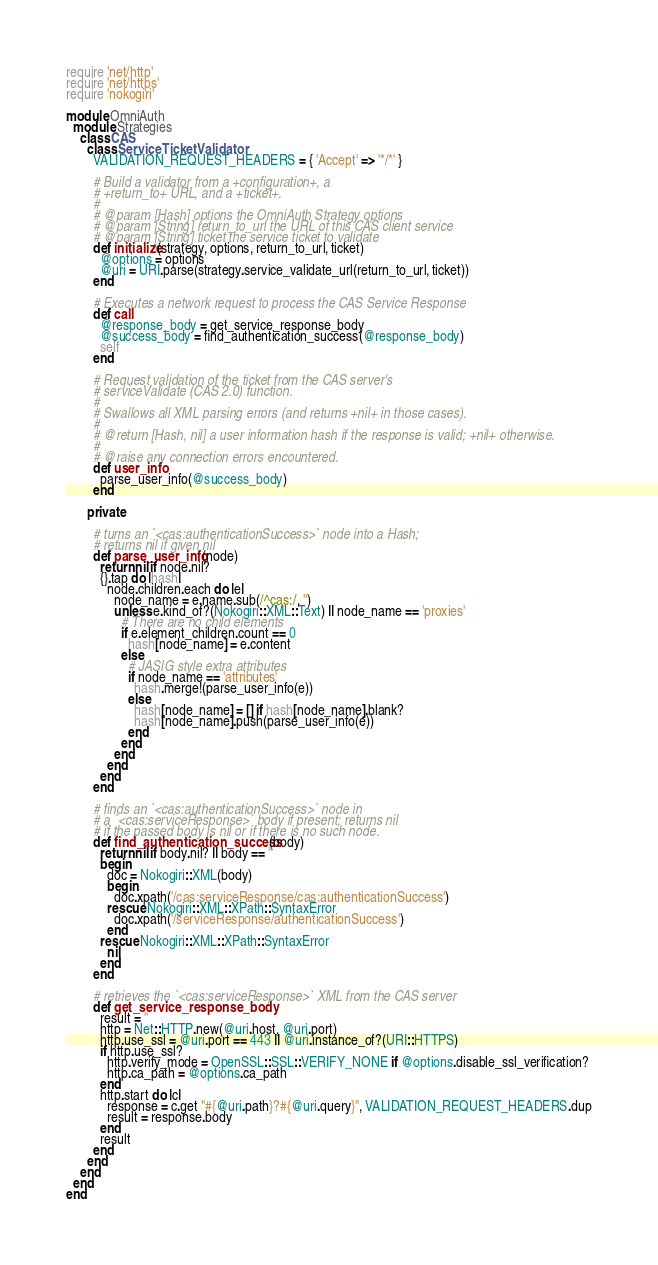<code> <loc_0><loc_0><loc_500><loc_500><_Ruby_>require 'net/http'
require 'net/https'
require 'nokogiri'

module OmniAuth
  module Strategies
    class CAS
      class ServiceTicketValidator
        VALIDATION_REQUEST_HEADERS = { 'Accept' => '*/*' }

        # Build a validator from a +configuration+, a
        # +return_to+ URL, and a +ticket+.
        #
        # @param [Hash] options the OmniAuth Strategy options
        # @param [String] return_to_url the URL of this CAS client service
        # @param [String] ticket the service ticket to validate
        def initialize(strategy, options, return_to_url, ticket)
          @options = options
          @uri = URI.parse(strategy.service_validate_url(return_to_url, ticket))
        end

        # Executes a network request to process the CAS Service Response
        def call
          @response_body = get_service_response_body
          @success_body = find_authentication_success(@response_body)
          self
        end

        # Request validation of the ticket from the CAS server's
        # serviceValidate (CAS 2.0) function.
        #
        # Swallows all XML parsing errors (and returns +nil+ in those cases).
        #
        # @return [Hash, nil] a user information hash if the response is valid; +nil+ otherwise.
        #
        # @raise any connection errors encountered.
        def user_info
          parse_user_info(@success_body)
        end

      private

        # turns an `<cas:authenticationSuccess>` node into a Hash;
        # returns nil if given nil
        def parse_user_info(node)
          return nil if node.nil?
          {}.tap do |hash|
            node.children.each do |e|
              node_name = e.name.sub(/^cas:/, '')
              unless e.kind_of?(Nokogiri::XML::Text) || node_name == 'proxies'
                # There are no child elements
                if e.element_children.count == 0
                  hash[node_name] = e.content
                else
                  # JASIG style extra attributes
                  if node_name == 'attributes'
                    hash.merge!(parse_user_info(e))
                  else
                    hash[node_name] = [] if hash[node_name].blank?
                    hash[node_name].push(parse_user_info(e))
                  end
                end
              end
            end
          end
        end

        # finds an `<cas:authenticationSuccess>` node in
        # a `<cas:serviceResponse>` body if present; returns nil
        # if the passed body is nil or if there is no such node.
        def find_authentication_success(body)
          return nil if body.nil? || body == ''
          begin
            doc = Nokogiri::XML(body)
            begin
              doc.xpath('/cas:serviceResponse/cas:authenticationSuccess')
            rescue Nokogiri::XML::XPath::SyntaxError
              doc.xpath('/serviceResponse/authenticationSuccess')
            end
          rescue Nokogiri::XML::XPath::SyntaxError
            nil
          end
        end

        # retrieves the `<cas:serviceResponse>` XML from the CAS server
        def get_service_response_body
          result = ''
          http = Net::HTTP.new(@uri.host, @uri.port)
          http.use_ssl = @uri.port == 443 || @uri.instance_of?(URI::HTTPS)
          if http.use_ssl?
            http.verify_mode = OpenSSL::SSL::VERIFY_NONE if @options.disable_ssl_verification?
            http.ca_path = @options.ca_path
          end
          http.start do |c|
            response = c.get "#{@uri.path}?#{@uri.query}", VALIDATION_REQUEST_HEADERS.dup
            result = response.body
          end
          result
        end
      end
    end
  end
end
</code> 